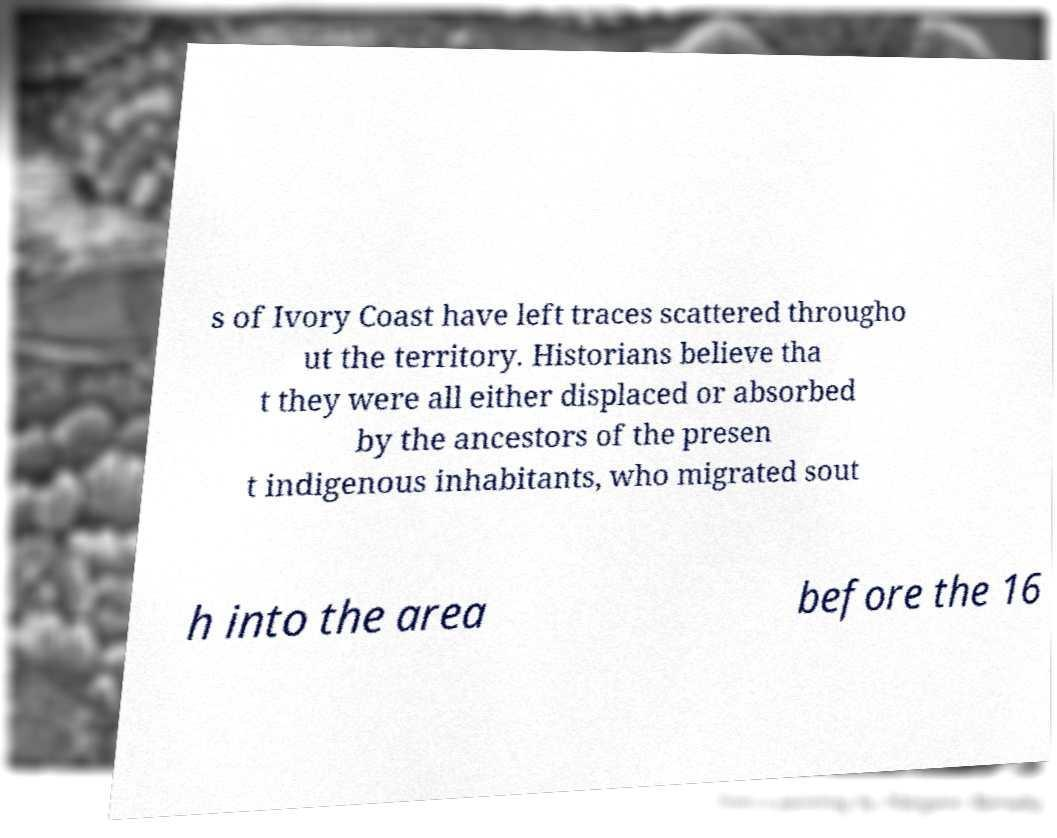Please identify and transcribe the text found in this image. s of Ivory Coast have left traces scattered througho ut the territory. Historians believe tha t they were all either displaced or absorbed by the ancestors of the presen t indigenous inhabitants, who migrated sout h into the area before the 16 